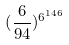<formula> <loc_0><loc_0><loc_500><loc_500>( \frac { 6 } { 9 4 } ) ^ { 6 ^ { 1 4 6 } }</formula> 